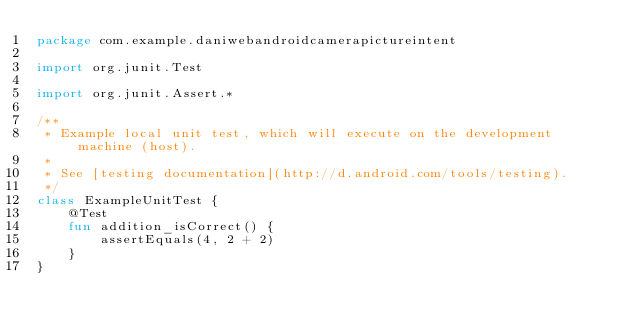Convert code to text. <code><loc_0><loc_0><loc_500><loc_500><_Kotlin_>package com.example.daniwebandroidcamerapictureintent

import org.junit.Test

import org.junit.Assert.*

/**
 * Example local unit test, which will execute on the development machine (host).
 *
 * See [testing documentation](http://d.android.com/tools/testing).
 */
class ExampleUnitTest {
    @Test
    fun addition_isCorrect() {
        assertEquals(4, 2 + 2)
    }
}</code> 